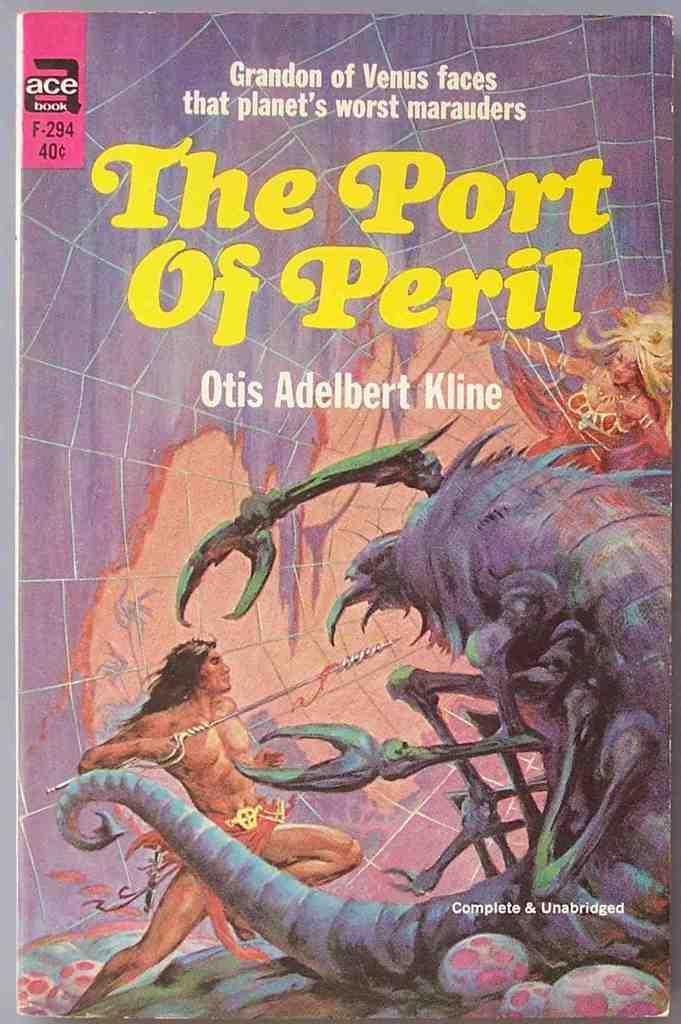Provide a one-sentence caption for the provided image. A science fiction book entitled "The Port of Peril". 